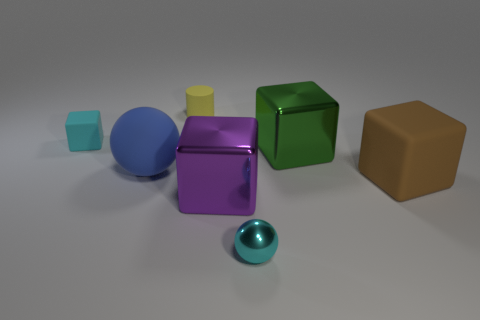Add 1 tiny brown matte blocks. How many objects exist? 8 Subtract all blocks. How many objects are left? 3 Add 4 large brown things. How many large brown things exist? 5 Subtract 0 red cylinders. How many objects are left? 7 Subtract all metal balls. Subtract all brown rubber objects. How many objects are left? 5 Add 2 brown matte objects. How many brown matte objects are left? 3 